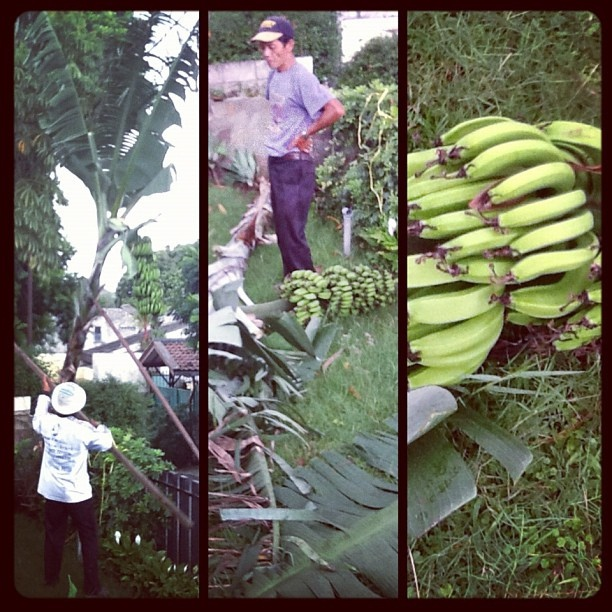Describe the objects in this image and their specific colors. I can see banana in black, khaki, olive, and darkgreen tones, people in black, white, gray, and darkgray tones, people in black, purple, pink, lavender, and violet tones, banana in black, gray, olive, darkgreen, and darkgray tones, and banana in black, darkgray, gray, and lightgreen tones in this image. 